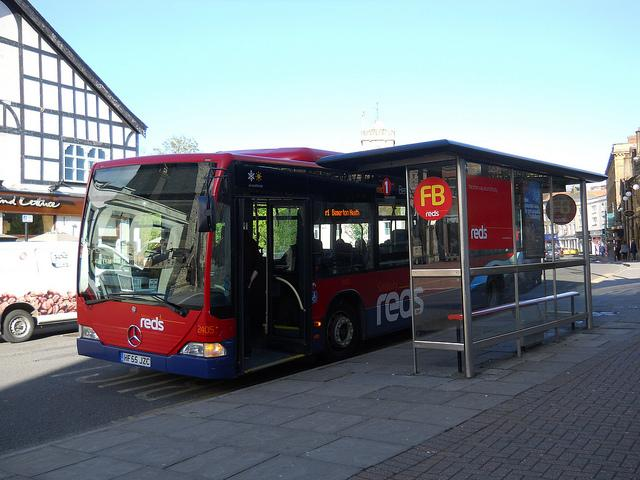What reason is the glass structure placed here?

Choices:
A) bus stop
B) sales kiosk
C) advertising only
D) telephone calls bus stop 